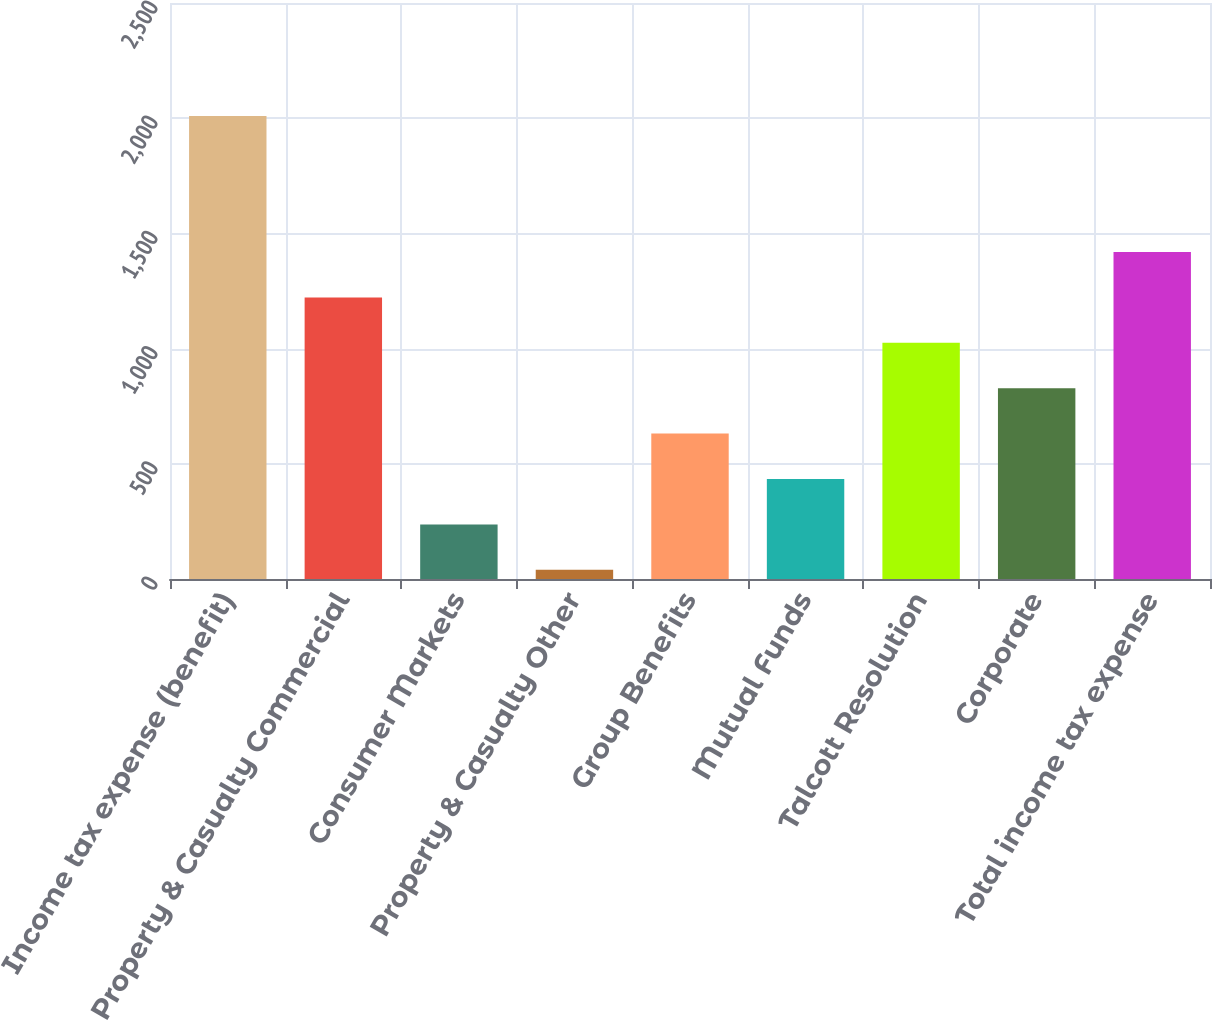Convert chart to OTSL. <chart><loc_0><loc_0><loc_500><loc_500><bar_chart><fcel>Income tax expense (benefit)<fcel>Property & Casualty Commercial<fcel>Consumer Markets<fcel>Property & Casualty Other<fcel>Group Benefits<fcel>Mutual Funds<fcel>Talcott Resolution<fcel>Corporate<fcel>Total income tax expense<nl><fcel>2010<fcel>1222<fcel>237<fcel>40<fcel>631<fcel>434<fcel>1025<fcel>828<fcel>1419<nl></chart> 